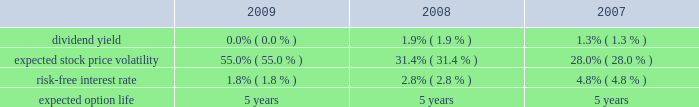Royal caribbean cruises ltd .
Notes to the consolidated financial statements 2014 ( continued ) note 9 .
Stock-based employee compensation we have four stock-based compensation plans , which provide for awards to our officers , directors and key employees .
The plans consist of a 1990 employee stock option plan , a 1995 incentive stock option plan , a 2000 stock award plan , and a 2008 equity plan .
The 1990 stock option plan and the 1995 incentive stock option plan terminated by their terms in march 2000 and february 2005 , respectively .
The 2000 stock award plan , as amended , and the 2008 equity plan provide for the issuance of ( i ) incentive and non-qualified stock options , ( ii ) stock appreciation rights , ( iii ) restricted stock , ( iv ) restricted stock units and ( v ) up to 13000000 performance shares of our common stock for the 2000 stock award plan and up to 5000000 performance shares of our common stock for the 2008 equity plan .
During any calendar year , no one individual shall be granted awards of more than 500000 shares .
Options and restricted stock units outstanding as of december 31 , 2009 vest in equal installments over four to five years from the date of grant .
Generally , options and restricted stock units are forfeited if the recipient ceases to be a director or employee before the shares vest .
Options are granted at a price not less than the fair value of the shares on the date of grant and expire not later than ten years after the date of grant .
We also provide an employee stock purchase plan to facilitate the purchase by employees of up to 800000 shares of common stock in the aggregate .
Offerings to employees are made on a quarterly basis .
Subject to certain limitations , the purchase price for each share of common stock is equal to 90% ( 90 % ) of the average of the market prices of the common stock as reported on the new york stock exchange on the first business day of the purchase period and the last business day of each month of the purchase period .
Shares of common stock of 65005 , 36836 and 20759 were issued under the espp at a weighted-average price of $ 12.78 , $ 20.97 and $ 37.25 during 2009 , 2008 and 2007 , respectively .
Under the chief executive officer 2019s employment agreement we contributed 10086 shares of our common stock quarterly , to a maximum of 806880 shares , to a trust on his behalf .
In january 2009 , the employment agreement and related trust agreement were amended .
Consequently , 768018 shares were distributed from the trust and future quarterly share distributions are issued directly to the chief executive officer .
Total compensation expenses recognized for employee stock-based compensation for the year ended december 31 , 2009 was $ 16.8 million .
Of this amount , $ 16.2 million was included within marketing , selling and administrative expenses and $ 0.6 million was included within payroll and related expenses .
Total compensation expense recognized for employee stock-based compensation for the year ended december 31 , 2008 was $ 5.7 million .
Of this amount , $ 6.4 million , which included a benefit of approximately $ 8.2 million due to a change in the employee forfeiture rate assumption was included within marketing , selling and administrative expenses and income of $ 0.7 million was included within payroll and related expenses which also included a benefit of approximately $ 1.0 million due to the change in the forfeiture rate .
Total compensation expenses recognized for employee stock-based compensation for the year ended december 31 , 2007 was $ 19.0 million .
Of this amount , $ 16.3 million was included within marketing , selling and administrative expenses and $ 2.7 million was included within payroll and related expenses .
The fair value of each stock option grant is estimated on the date of grant using the black-scholes option pricing model .
The estimated fair value of stock options , less estimated forfeitures , is amortized over the vesting period using the graded-vesting method .
The assumptions used in the black-scholes option-pricing model are as follows : expected volatility was based on a combination of historical and implied volatilities .
The risk-free interest rate is based on united states treasury zero coupon issues with a remaining term equal to the expected option life assumed at the date of grant .
The expected term was calculated based on historical experience and represents the time period options actually remain outstanding .
We estimate forfeitures based on historical pre-vesting forfeiture rates and revise those estimates as appropriate to reflect actual experience .
In 2008 , we increased our estimated forfeiture rate from 4% ( 4 % ) for options and 8.5% ( 8.5 % ) for restricted stock units to 20% ( 20 % ) to reflect changes in employee retention rates. .

What was the percent of the increase in the expected stock price volatility from 2008 to 2009? 
Computations: ((55.0 - 31.4) / 31.4)
Answer: 0.75159. 